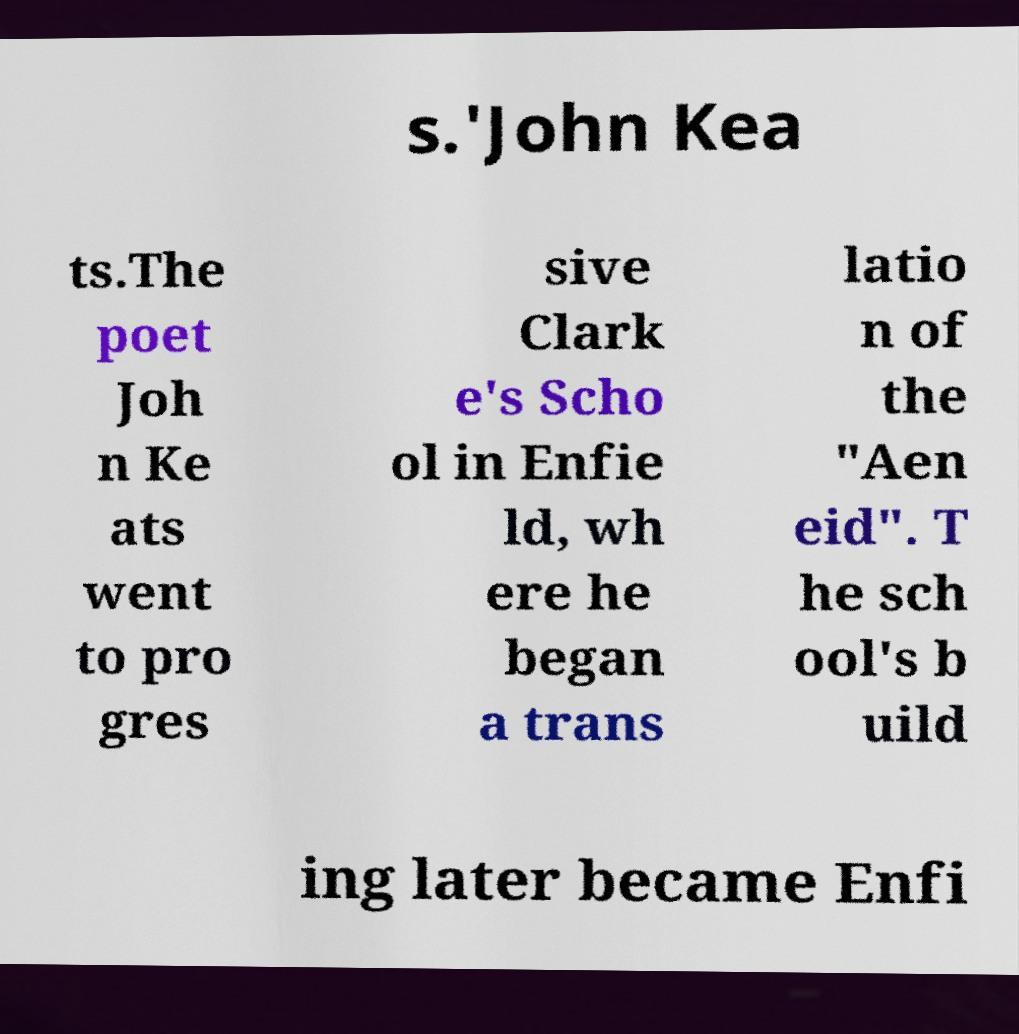Could you assist in decoding the text presented in this image and type it out clearly? s.'John Kea ts.The poet Joh n Ke ats went to pro gres sive Clark e's Scho ol in Enfie ld, wh ere he began a trans latio n of the "Aen eid". T he sch ool's b uild ing later became Enfi 